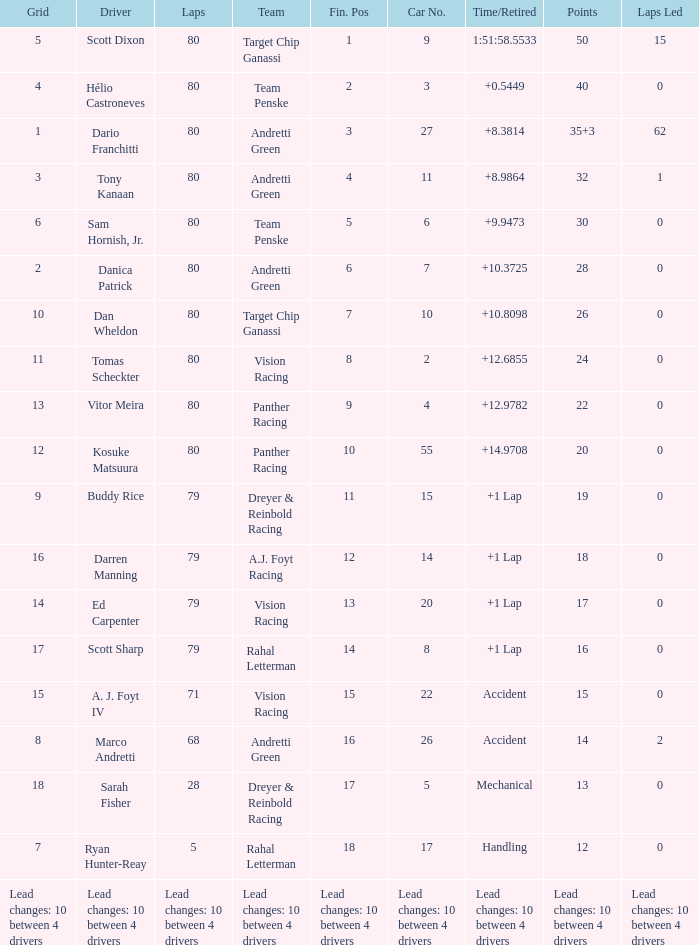What grid has 24 points? 11.0. 